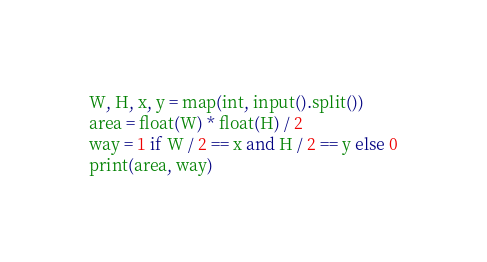Convert code to text. <code><loc_0><loc_0><loc_500><loc_500><_Python_>W, H, x, y = map(int, input().split())
area = float(W) * float(H) / 2
way = 1 if W / 2 == x and H / 2 == y else 0
print(area, way)</code> 